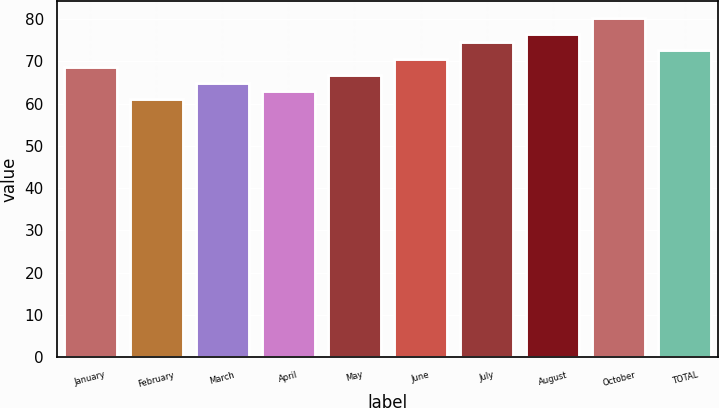<chart> <loc_0><loc_0><loc_500><loc_500><bar_chart><fcel>January<fcel>February<fcel>March<fcel>April<fcel>May<fcel>June<fcel>July<fcel>August<fcel>October<fcel>TOTAL<nl><fcel>68.75<fcel>61.07<fcel>64.91<fcel>62.99<fcel>66.83<fcel>70.67<fcel>74.51<fcel>76.43<fcel>80.26<fcel>72.59<nl></chart> 